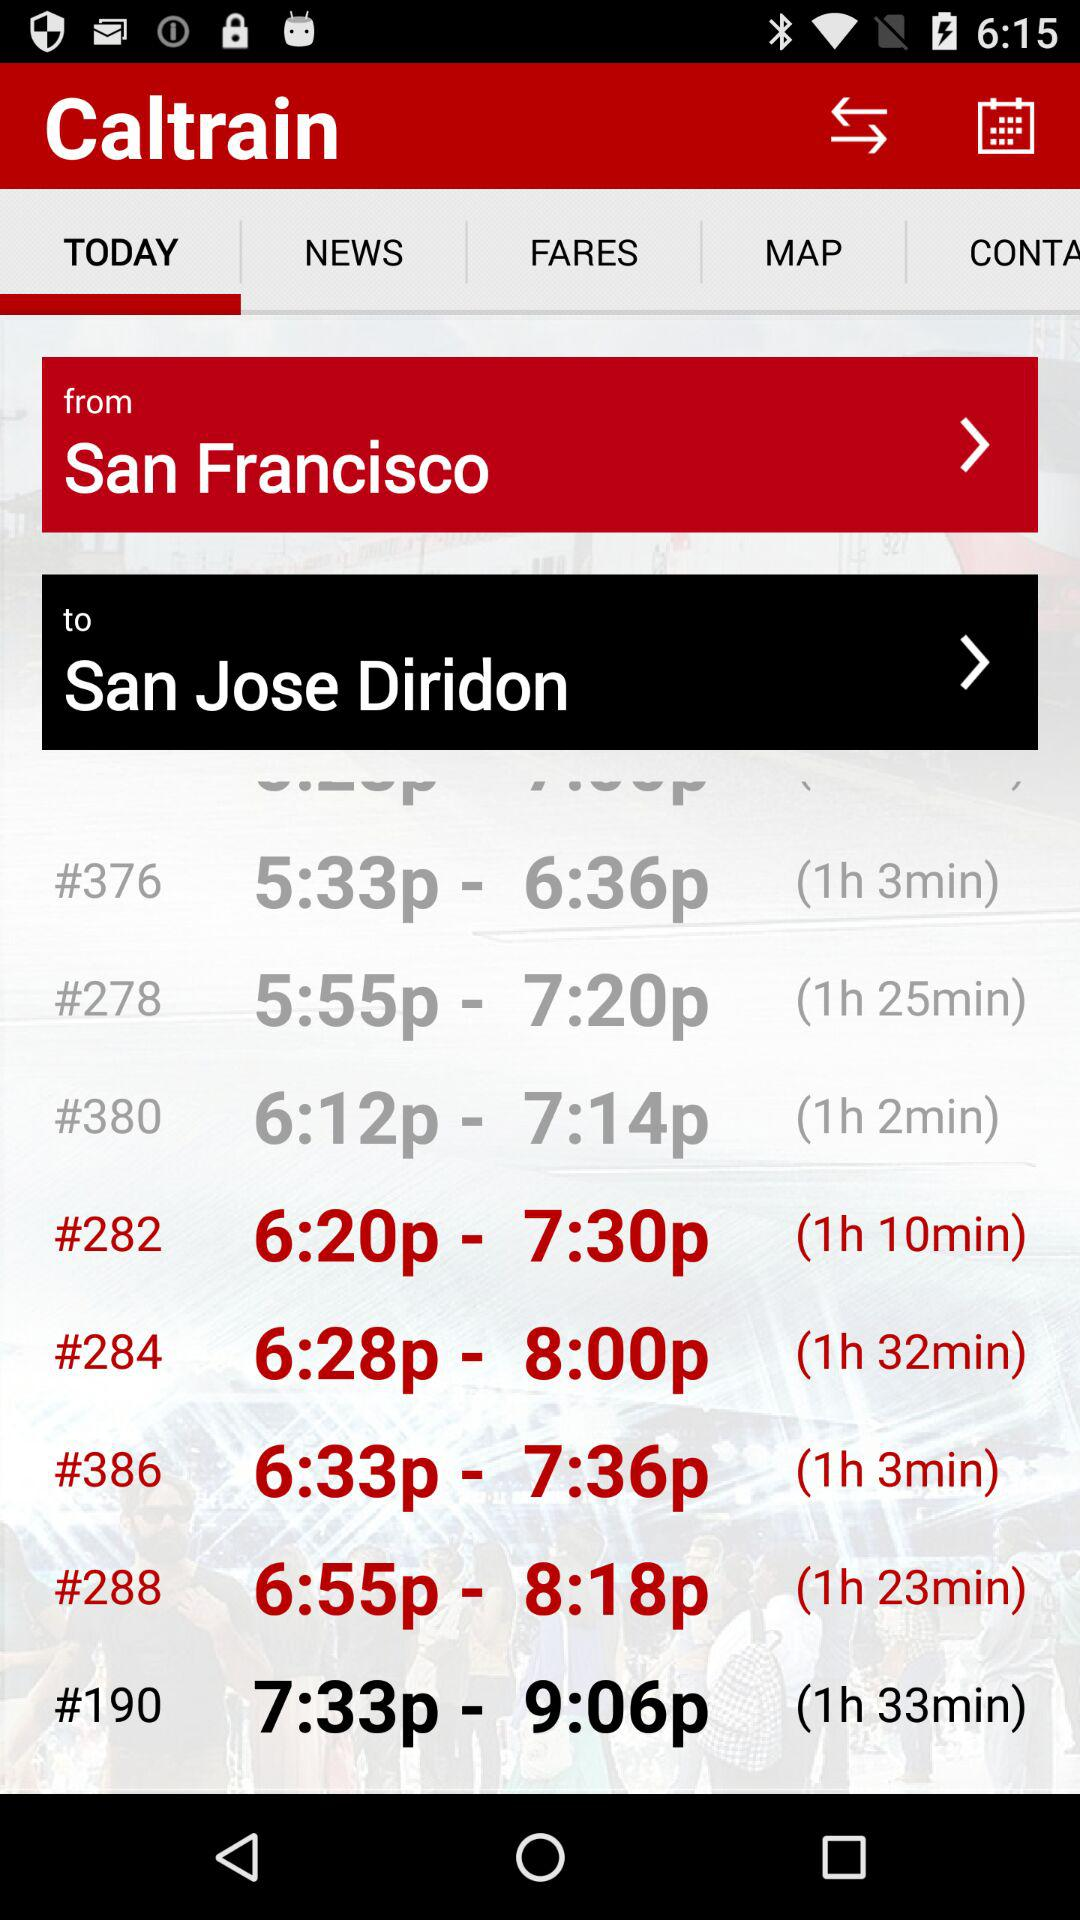Which tab is selected? The selected tab is "TODAY". 